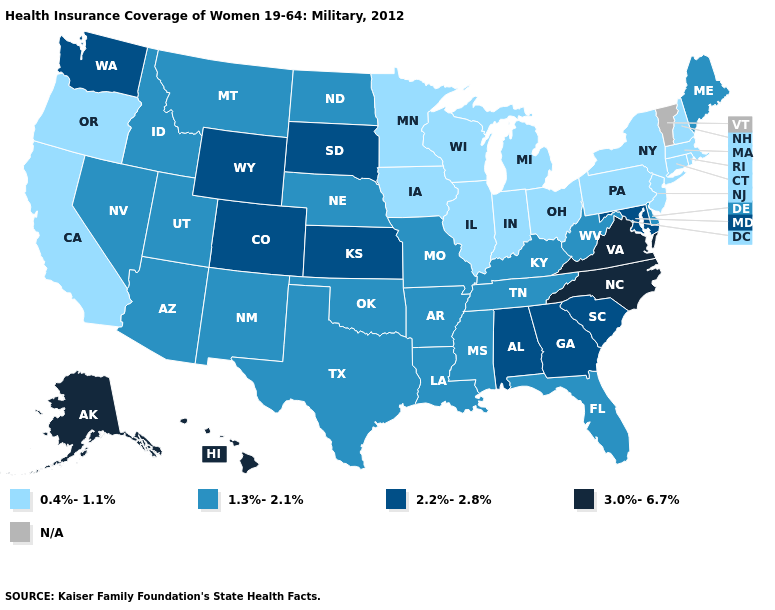What is the value of Arkansas?
Write a very short answer. 1.3%-2.1%. What is the lowest value in the Northeast?
Answer briefly. 0.4%-1.1%. What is the value of Illinois?
Concise answer only. 0.4%-1.1%. Name the states that have a value in the range N/A?
Quick response, please. Vermont. Does Alaska have the highest value in the USA?
Be succinct. Yes. What is the value of New Jersey?
Be succinct. 0.4%-1.1%. What is the value of Kentucky?
Write a very short answer. 1.3%-2.1%. What is the lowest value in the USA?
Answer briefly. 0.4%-1.1%. What is the value of Ohio?
Concise answer only. 0.4%-1.1%. Does Wisconsin have the highest value in the USA?
Quick response, please. No. Among the states that border Alabama , does Georgia have the highest value?
Quick response, please. Yes. Which states have the lowest value in the USA?
Short answer required. California, Connecticut, Illinois, Indiana, Iowa, Massachusetts, Michigan, Minnesota, New Hampshire, New Jersey, New York, Ohio, Oregon, Pennsylvania, Rhode Island, Wisconsin. Name the states that have a value in the range N/A?
Be succinct. Vermont. Does Alaska have the highest value in the West?
Keep it brief. Yes. 